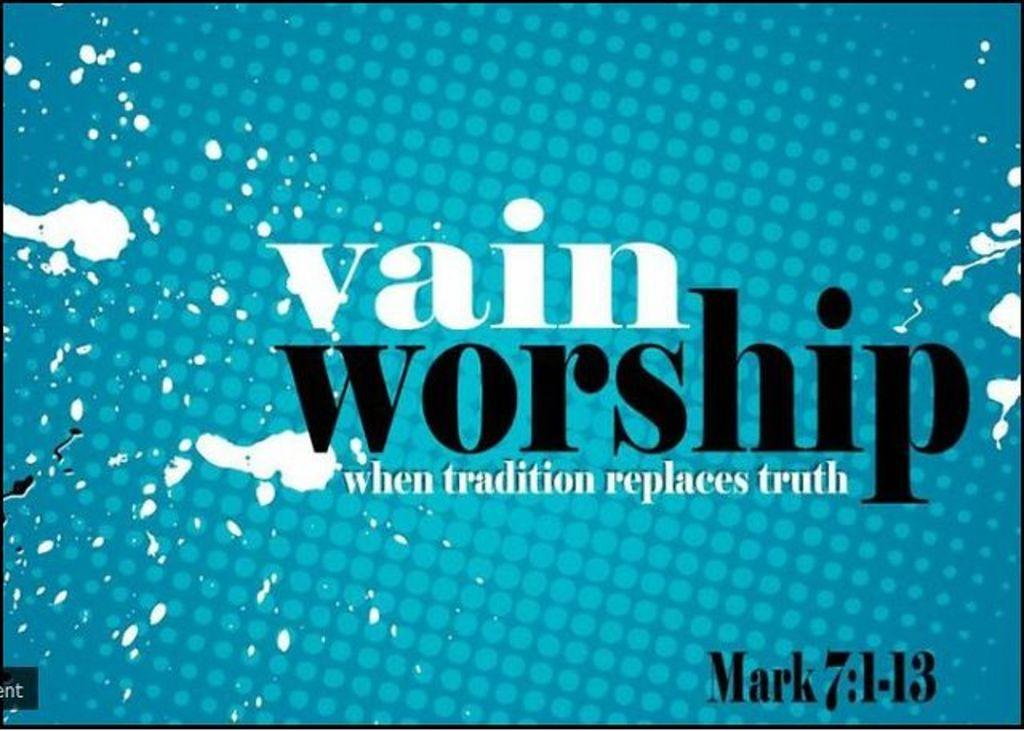<image>
Share a concise interpretation of the image provided. A blue graphic that says vain worship when tradition replaces truth 